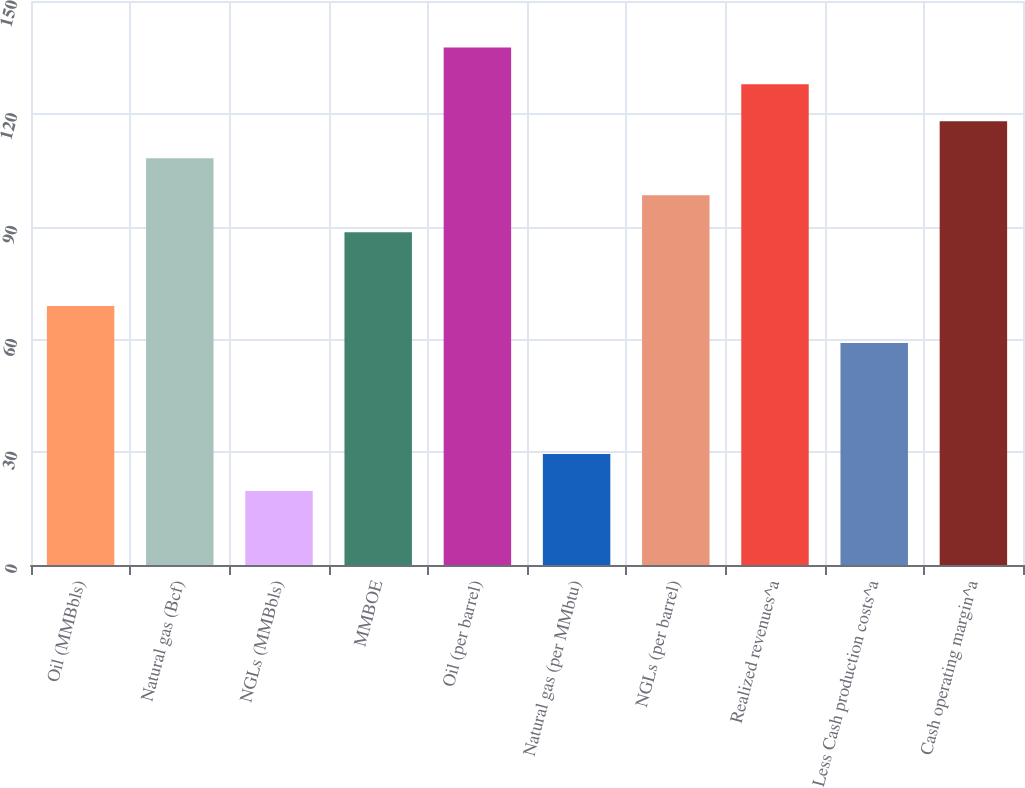Convert chart to OTSL. <chart><loc_0><loc_0><loc_500><loc_500><bar_chart><fcel>Oil (MMBbls)<fcel>Natural gas (Bcf)<fcel>NGLs (MMBbls)<fcel>MMBOE<fcel>Oil (per barrel)<fcel>Natural gas (per MMbtu)<fcel>NGLs (per barrel)<fcel>Realized revenues^a<fcel>Less Cash production costs^a<fcel>Cash operating margin^a<nl><fcel>68.85<fcel>108.17<fcel>19.7<fcel>88.51<fcel>137.66<fcel>29.53<fcel>98.34<fcel>127.83<fcel>59.02<fcel>118<nl></chart> 